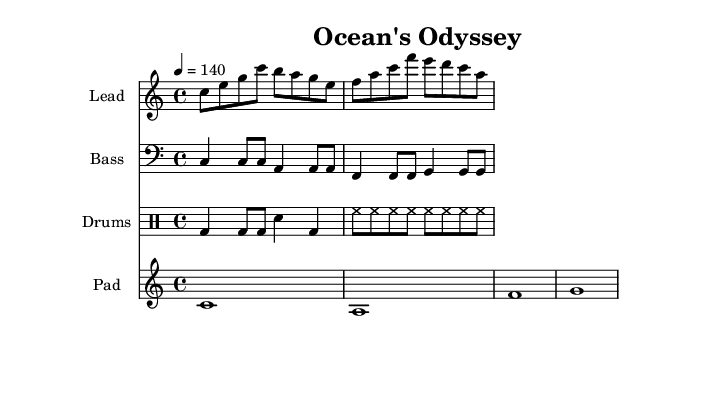What is the key signature of this music? The key signature is C major, which has no sharps or flats.
Answer: C major What is the time signature of this music? The time signature is indicated at the beginning of the score and is 4/4, meaning there are four beats per measure.
Answer: 4/4 What is the tempo marking for this piece? The tempo marking shows that it should be played at 140 beats per minute, indicating the speed of the music.
Answer: 140 How many measures does the lead part contain? Counting the measures in the chiptuneLead part, there are a total of 2 measures shown in the score.
Answer: 2 Which instruments are included in this score? The score includes a lead instrument, a bass instrument, a drumset, and a synth pad, as indicated by the different staves.
Answer: Lead, Bass, Drums, Pad What rhythmic pattern is used for the digital percussion? The rhythmic pattern for the digital percussion consists of a bass drum hit followed by hi-hats and snare, creating a driving rhythm typical in electronic music.
Answer: Bass, Hi-hat, Snare What is the note value of the longest note in the synth pad part? Inspecting the synthPad part, the longest note value is a whole note, which lasts four beats in the 4/4 time signature.
Answer: Whole note 